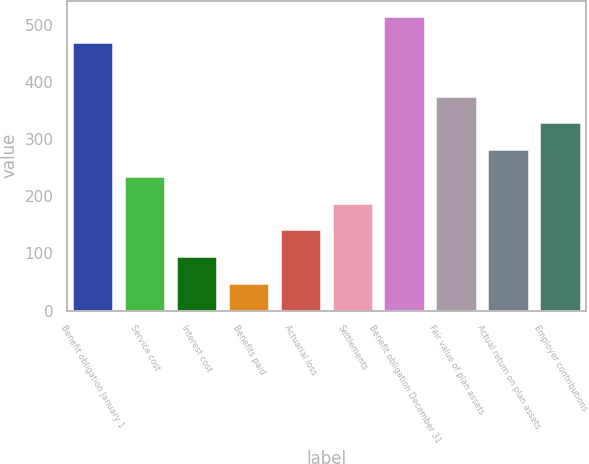Convert chart. <chart><loc_0><loc_0><loc_500><loc_500><bar_chart><fcel>Benefit obligation January 1<fcel>Service cost<fcel>Interest cost<fcel>Benefits paid<fcel>Actuarial loss<fcel>Settlements<fcel>Benefit obligation December 31<fcel>Fair value of plan assets<fcel>Actual return on plan assets<fcel>Employer contributions<nl><fcel>469<fcel>235.5<fcel>95.4<fcel>48.7<fcel>142.1<fcel>188.8<fcel>515.7<fcel>375.6<fcel>282.2<fcel>328.9<nl></chart> 